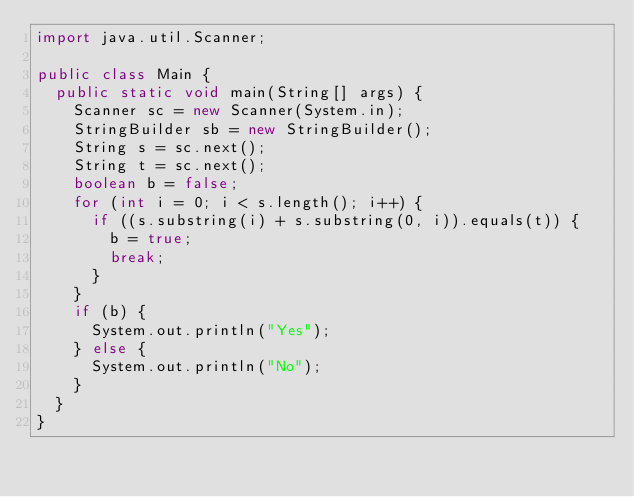Convert code to text. <code><loc_0><loc_0><loc_500><loc_500><_Java_>import java.util.Scanner;

public class Main {
	public static void main(String[] args) {
		Scanner sc = new Scanner(System.in);
		StringBuilder sb = new StringBuilder();
		String s = sc.next();
		String t = sc.next();
		boolean b = false;
		for (int i = 0; i < s.length(); i++) {
			if ((s.substring(i) + s.substring(0, i)).equals(t)) {
				b = true;
				break;
			}
		}
		if (b) {
			System.out.println("Yes");
		} else {
			System.out.println("No");
		}
	}
}
</code> 